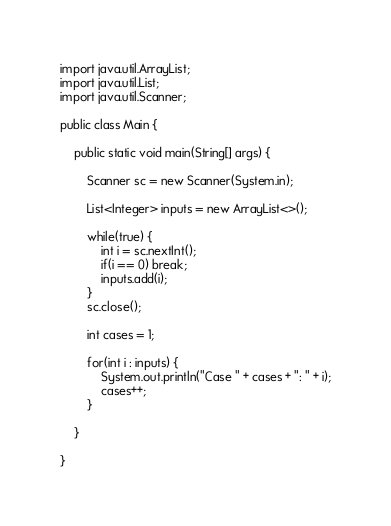<code> <loc_0><loc_0><loc_500><loc_500><_Java_>import java.util.ArrayList;
import java.util.List;
import java.util.Scanner;

public class Main {

	public static void main(String[] args) {
		
		Scanner sc = new Scanner(System.in);
		
		List<Integer> inputs = new ArrayList<>();
		
		while(true) {
			int i = sc.nextInt();
			if(i == 0) break;
			inputs.add(i);
		}
		sc.close();
		
		int cases = 1;
		
		for(int i : inputs) {
			System.out.println("Case " + cases + ": " + i);
			cases++;
		}
		
	}

}</code> 